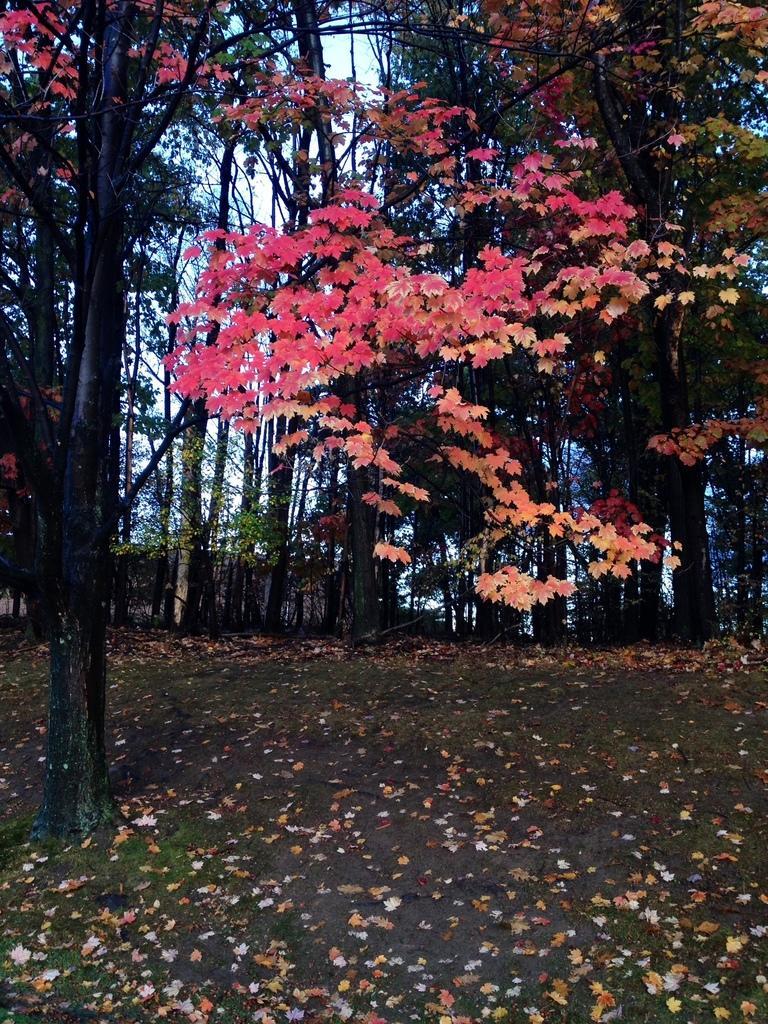In one or two sentences, can you explain what this image depicts? In this image I can see few leaves on the ground and I can see few trees which are green, pink, orange and black in color. In the background I can see the sky. 